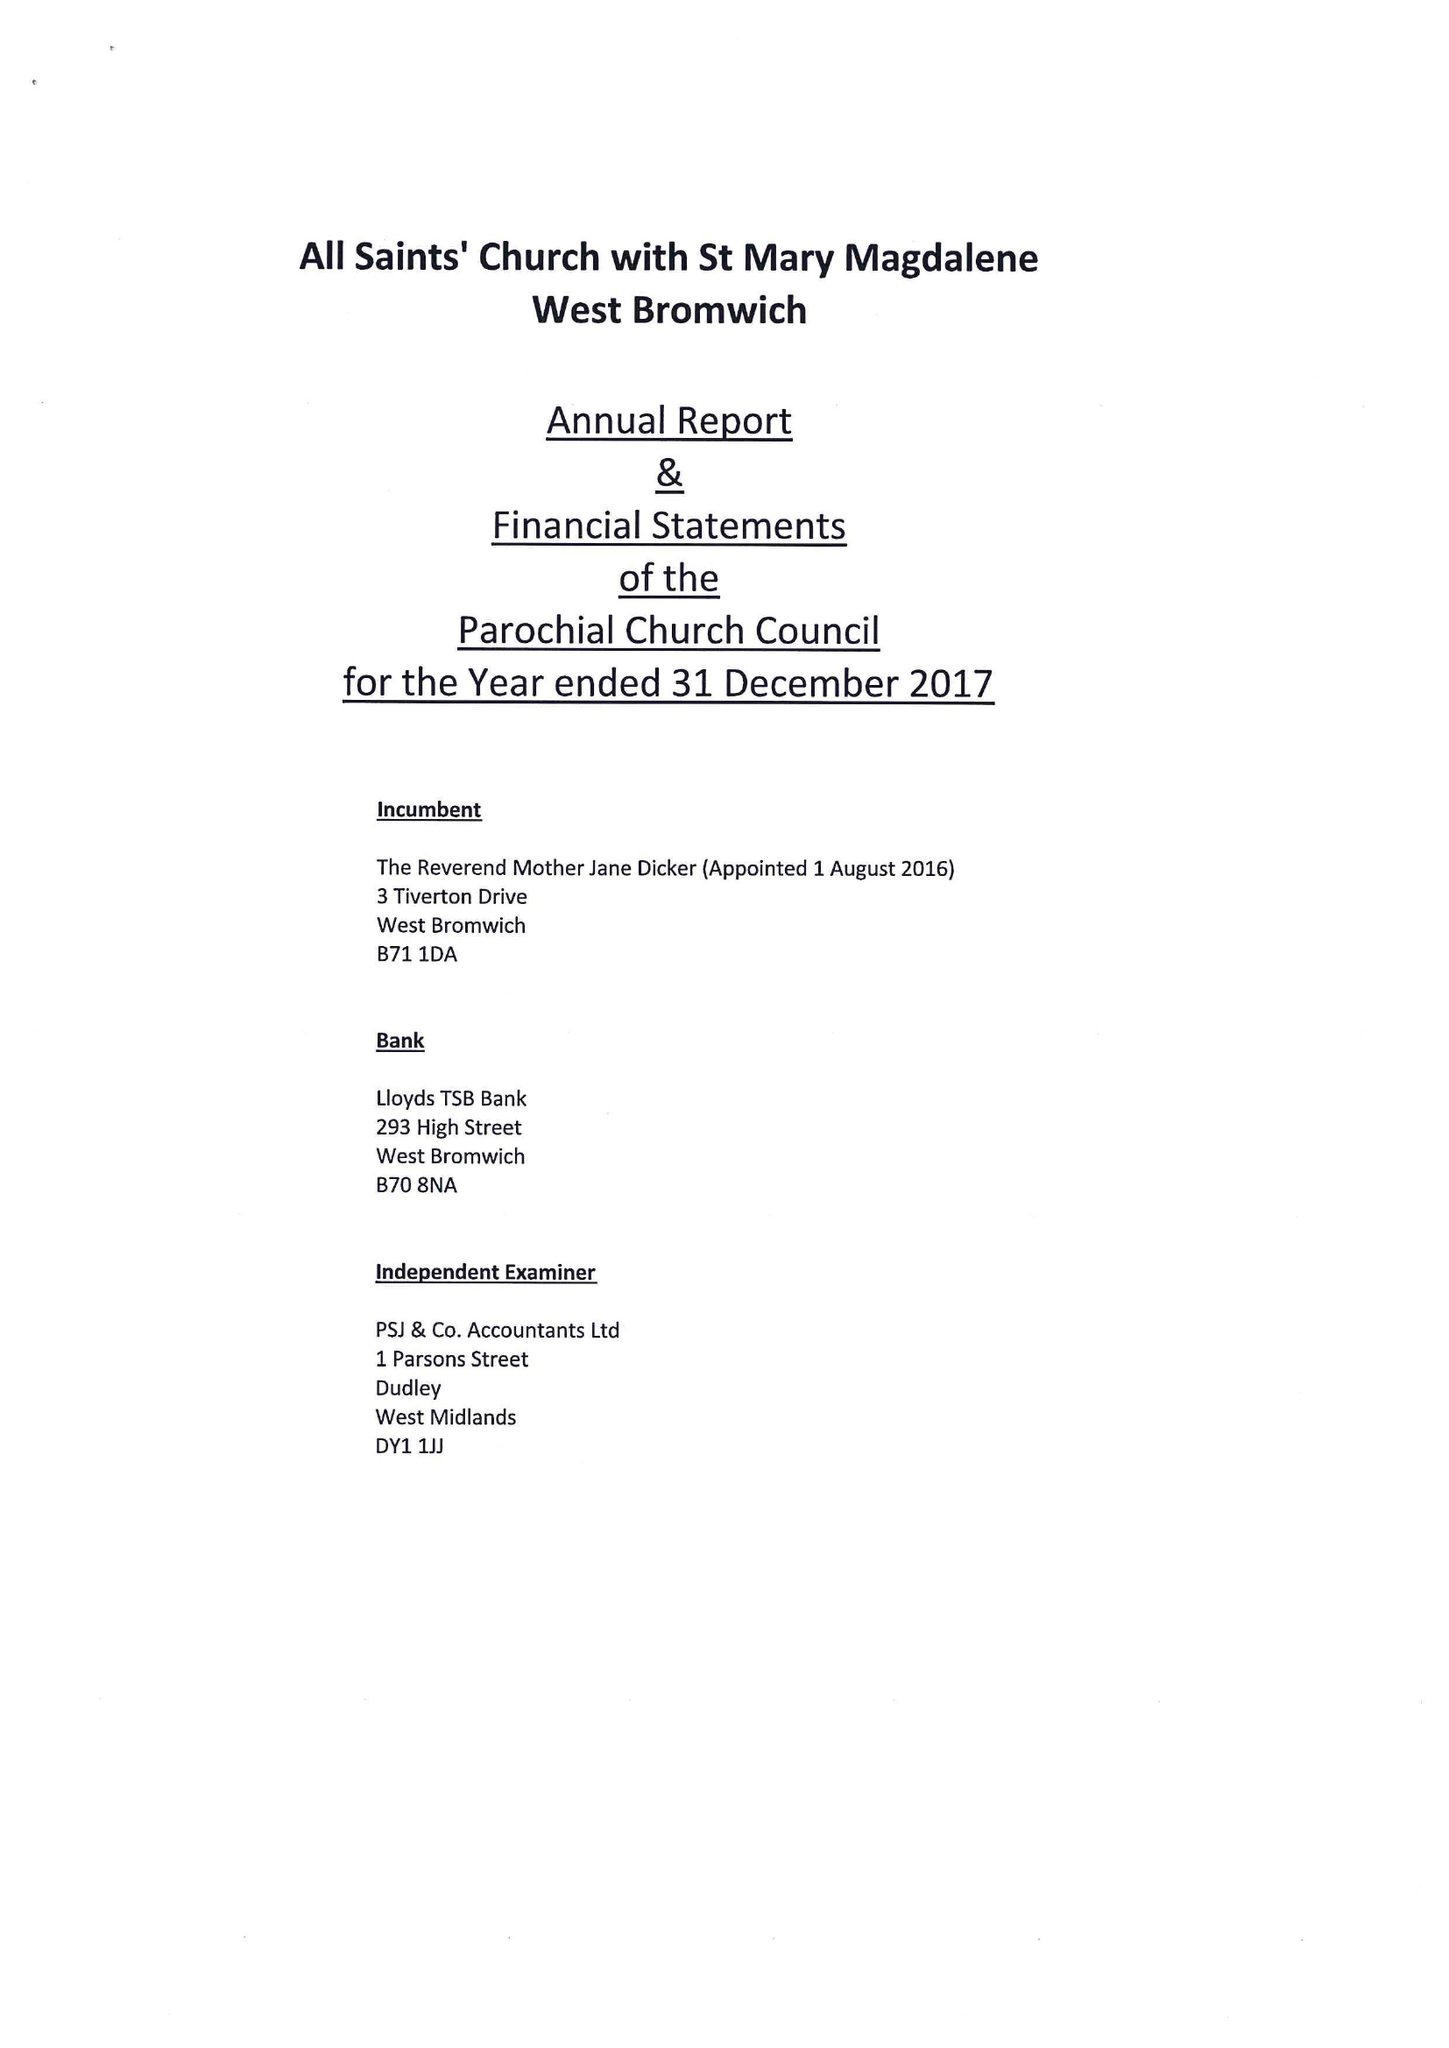What is the value for the charity_name?
Answer the question using a single word or phrase. The Parochial Church Council Of The Ecclesiastical Parish Of West Bromwich 